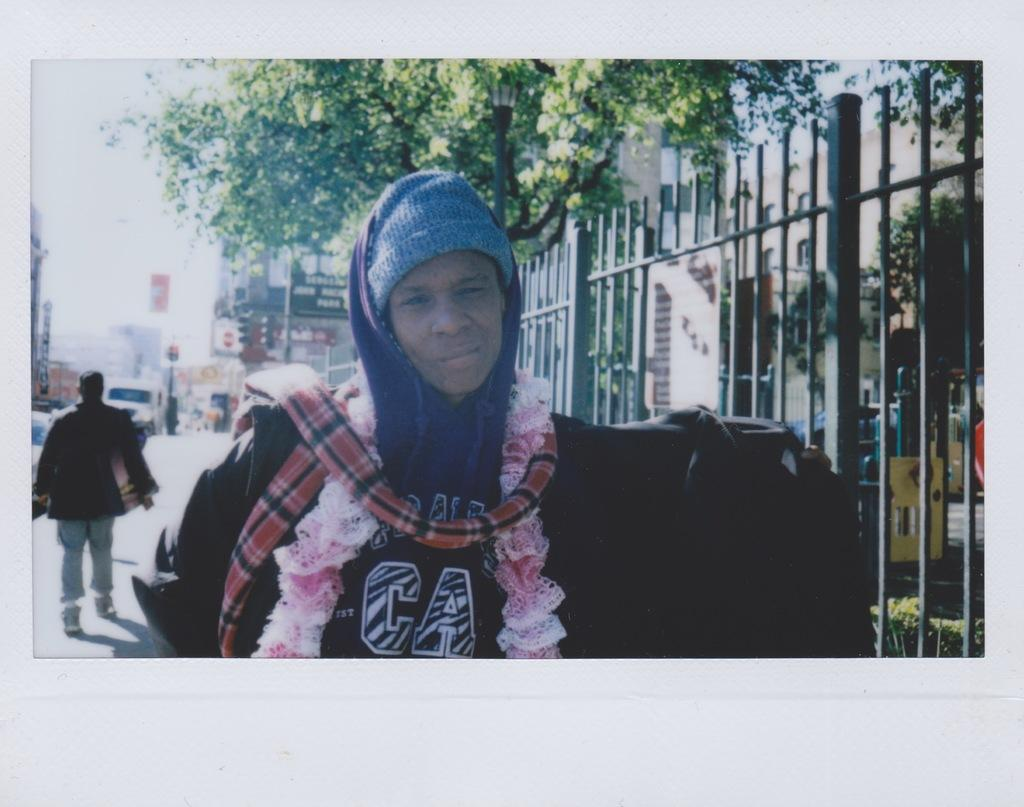Provide a one-sentence caption for the provided image. A young woman wearing a hat and other clothing poses for the camera. 